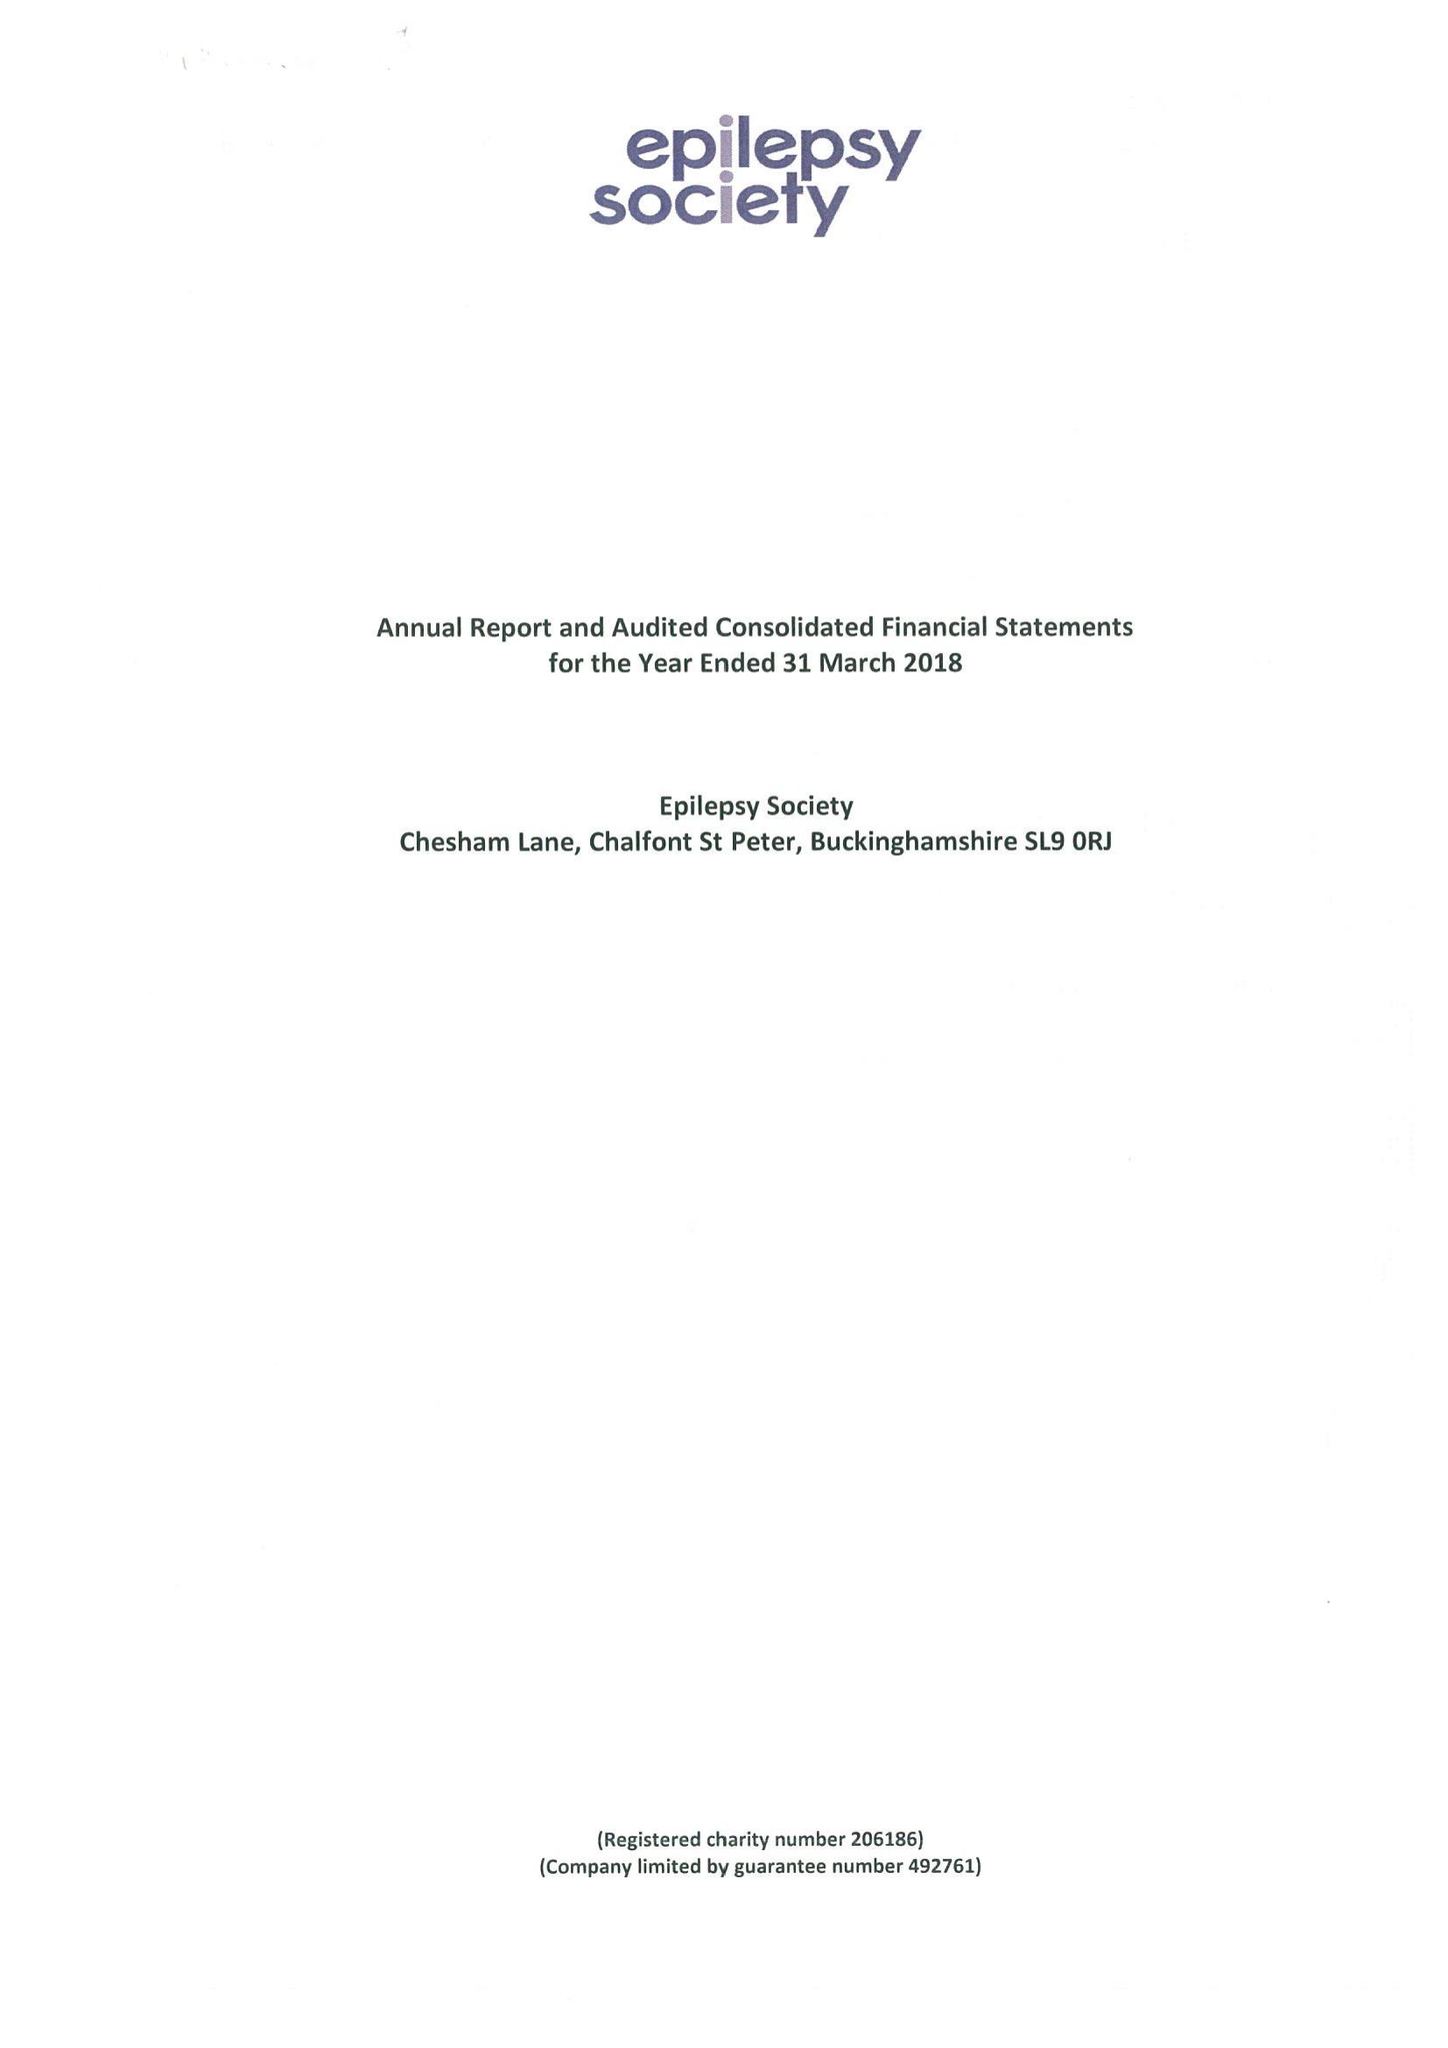What is the value for the address__post_town?
Answer the question using a single word or phrase. GERRARDS CROSS 